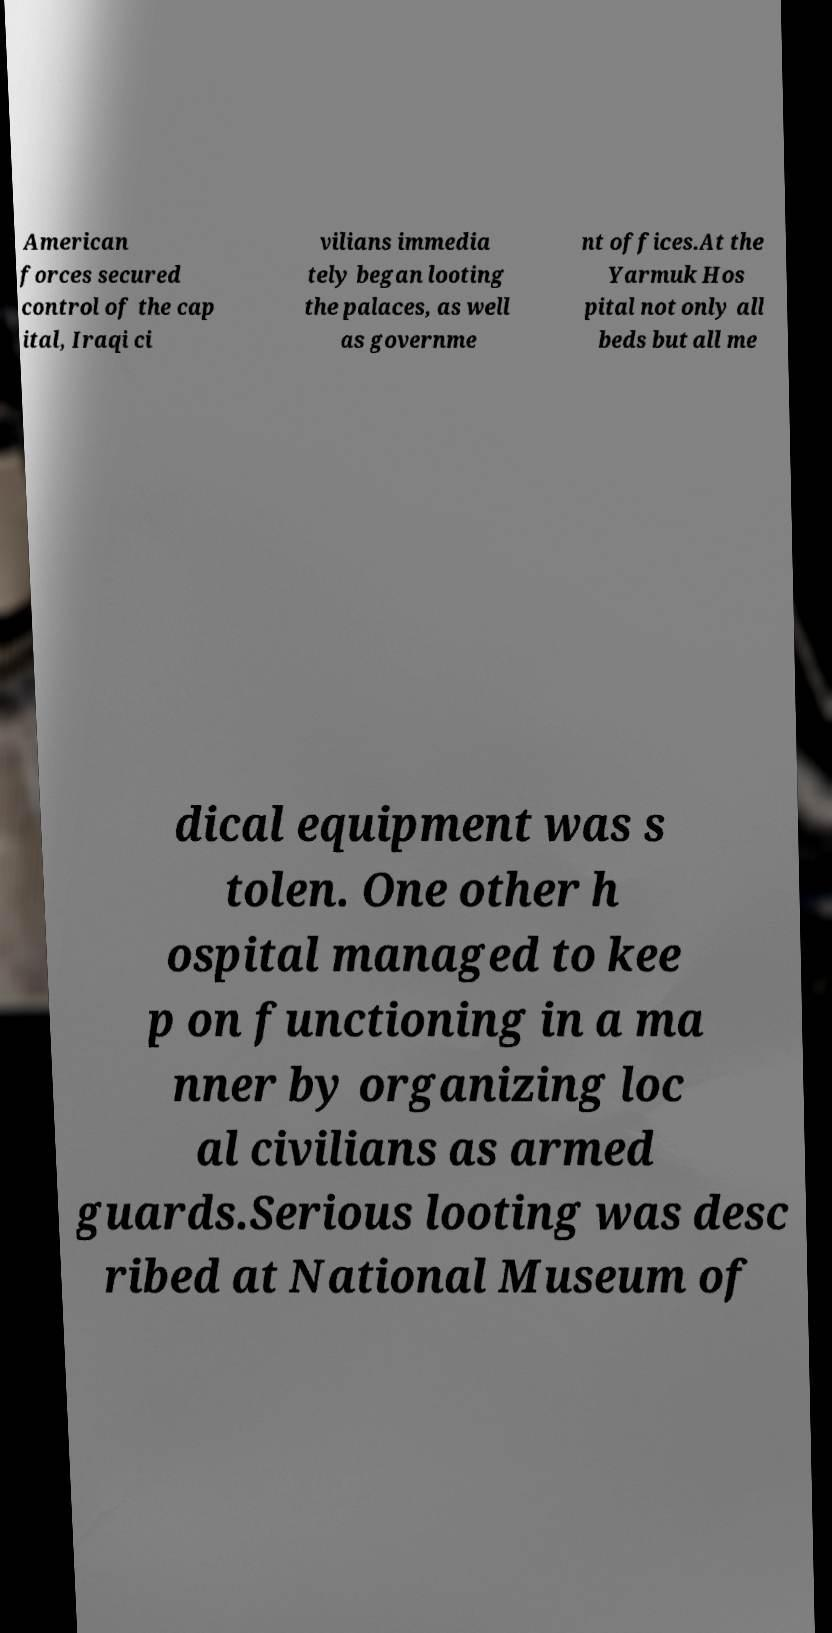Could you extract and type out the text from this image? American forces secured control of the cap ital, Iraqi ci vilians immedia tely began looting the palaces, as well as governme nt offices.At the Yarmuk Hos pital not only all beds but all me dical equipment was s tolen. One other h ospital managed to kee p on functioning in a ma nner by organizing loc al civilians as armed guards.Serious looting was desc ribed at National Museum of 